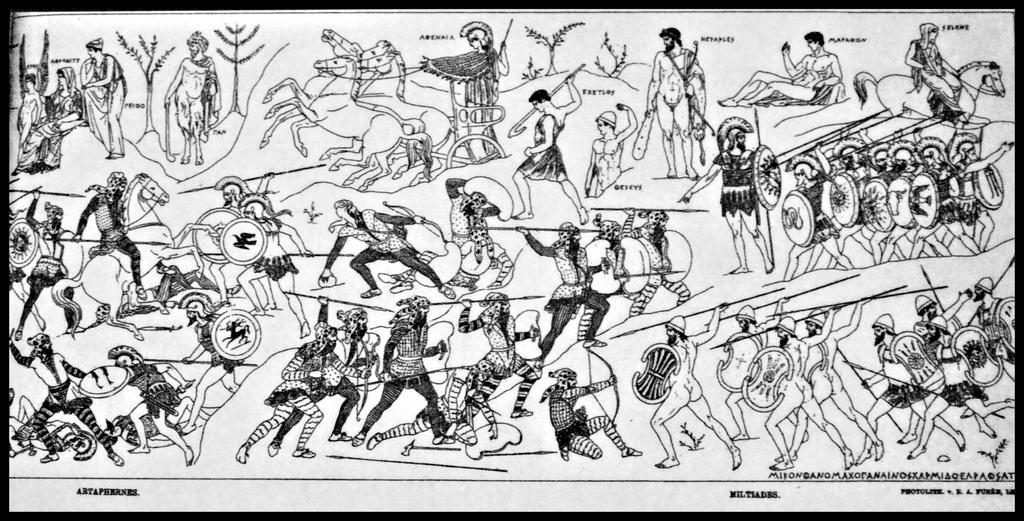What is the color scheme of the image? The image is black and white. What is the main object in the image? There is a poster in the image. What types of images are on the poster? The poster contains images of humans and horses. Is there any text on the poster? Yes, there is text on the poster. How many bikes are depicted on the poster? There are no bikes present on the poster; it contains images of humans and horses. What type of impulse can be seen affecting the feet of the humans in the image? There are no humans or feet visible in the image, as it only features a poster with images of humans and horses. 